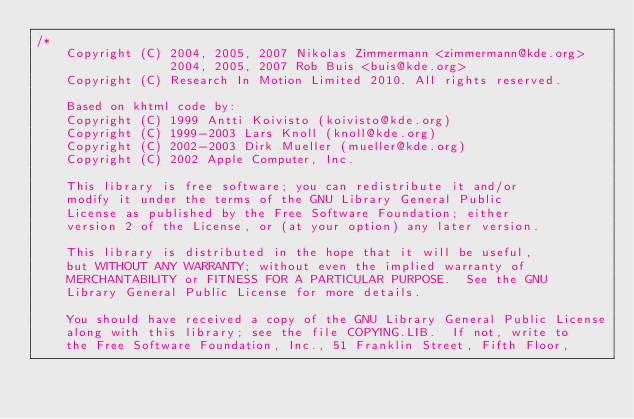<code> <loc_0><loc_0><loc_500><loc_500><_C++_>/*
    Copyright (C) 2004, 2005, 2007 Nikolas Zimmermann <zimmermann@kde.org>
                  2004, 2005, 2007 Rob Buis <buis@kde.org>
    Copyright (C) Research In Motion Limited 2010. All rights reserved.

    Based on khtml code by:
    Copyright (C) 1999 Antti Koivisto (koivisto@kde.org)
    Copyright (C) 1999-2003 Lars Knoll (knoll@kde.org)
    Copyright (C) 2002-2003 Dirk Mueller (mueller@kde.org)
    Copyright (C) 2002 Apple Computer, Inc.

    This library is free software; you can redistribute it and/or
    modify it under the terms of the GNU Library General Public
    License as published by the Free Software Foundation; either
    version 2 of the License, or (at your option) any later version.

    This library is distributed in the hope that it will be useful,
    but WITHOUT ANY WARRANTY; without even the implied warranty of
    MERCHANTABILITY or FITNESS FOR A PARTICULAR PURPOSE.  See the GNU
    Library General Public License for more details.

    You should have received a copy of the GNU Library General Public License
    along with this library; see the file COPYING.LIB.  If not, write to
    the Free Software Foundation, Inc., 51 Franklin Street, Fifth Floor,</code> 